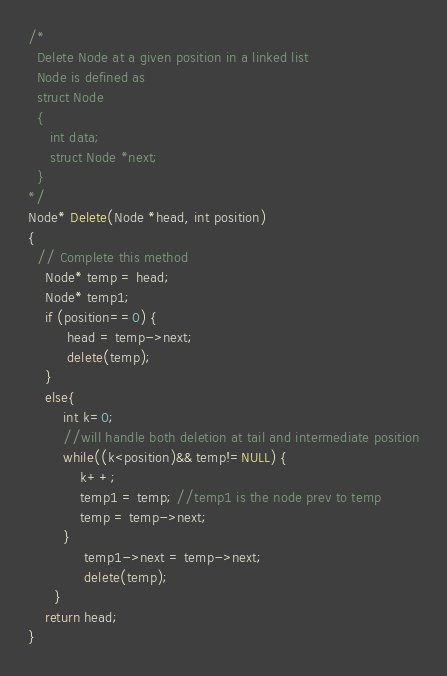<code> <loc_0><loc_0><loc_500><loc_500><_C++_>/*
  Delete Node at a given position in a linked list 
  Node is defined as 
  struct Node
  {
     int data;
     struct Node *next;
  }
*/
Node* Delete(Node *head, int position)
{
  // Complete this method
    Node* temp = head;
    Node* temp1;
    if (position==0) {
         head = temp->next;
         delete(temp);   
    }
    else{ 
        int k=0;
        //will handle both deletion at tail and intermediate position
        while((k<position)&& temp!=NULL) {
            k++;
            temp1 = temp; //temp1 is the node prev to temp
            temp = temp->next;
        }
             temp1->next = temp->next;
             delete(temp);
      }
    return head;
}
</code> 